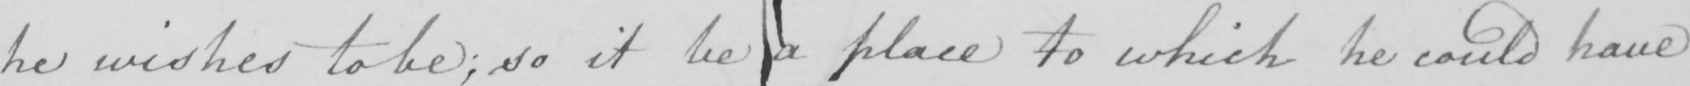What is written in this line of handwriting? he wishes to be ; so it be a place to which he could have 